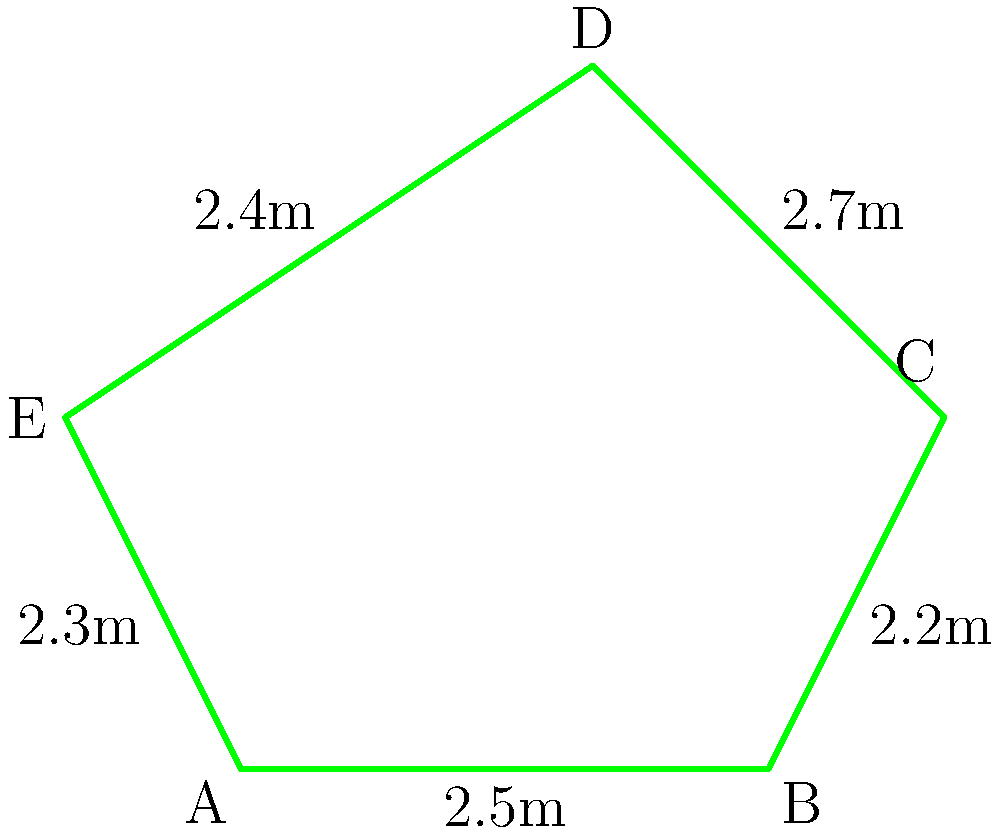As a nature enthusiast creating a spiritual garden, you've designed a pentagonal garden bed inspired by sacred geometry. The side lengths of the pentagon are 2.5m, 2.2m, 2.7m, 2.4m, and 2.3m. Calculate the perimeter of this sacred garden bed. To calculate the perimeter of the pentagonal garden bed, we need to sum up the lengths of all sides. Let's approach this step-by-step:

1) We have five sides with the following lengths:
   Side 1: 2.5m
   Side 2: 2.2m
   Side 3: 2.7m
   Side 4: 2.4m
   Side 5: 2.3m

2) The perimeter is the sum of all side lengths. We can express this mathematically as:

   $$P = s_1 + s_2 + s_3 + s_4 + s_5$$

   Where $P$ is the perimeter and $s_1, s_2, s_3, s_4, s_5$ are the side lengths.

3) Let's substitute the values:

   $$P = 2.5 + 2.2 + 2.7 + 2.4 + 2.3$$

4) Now, we simply need to add these numbers:

   $$P = 12.1$$

Therefore, the perimeter of the pentagonal garden bed is 12.1 meters.
Answer: 12.1m 